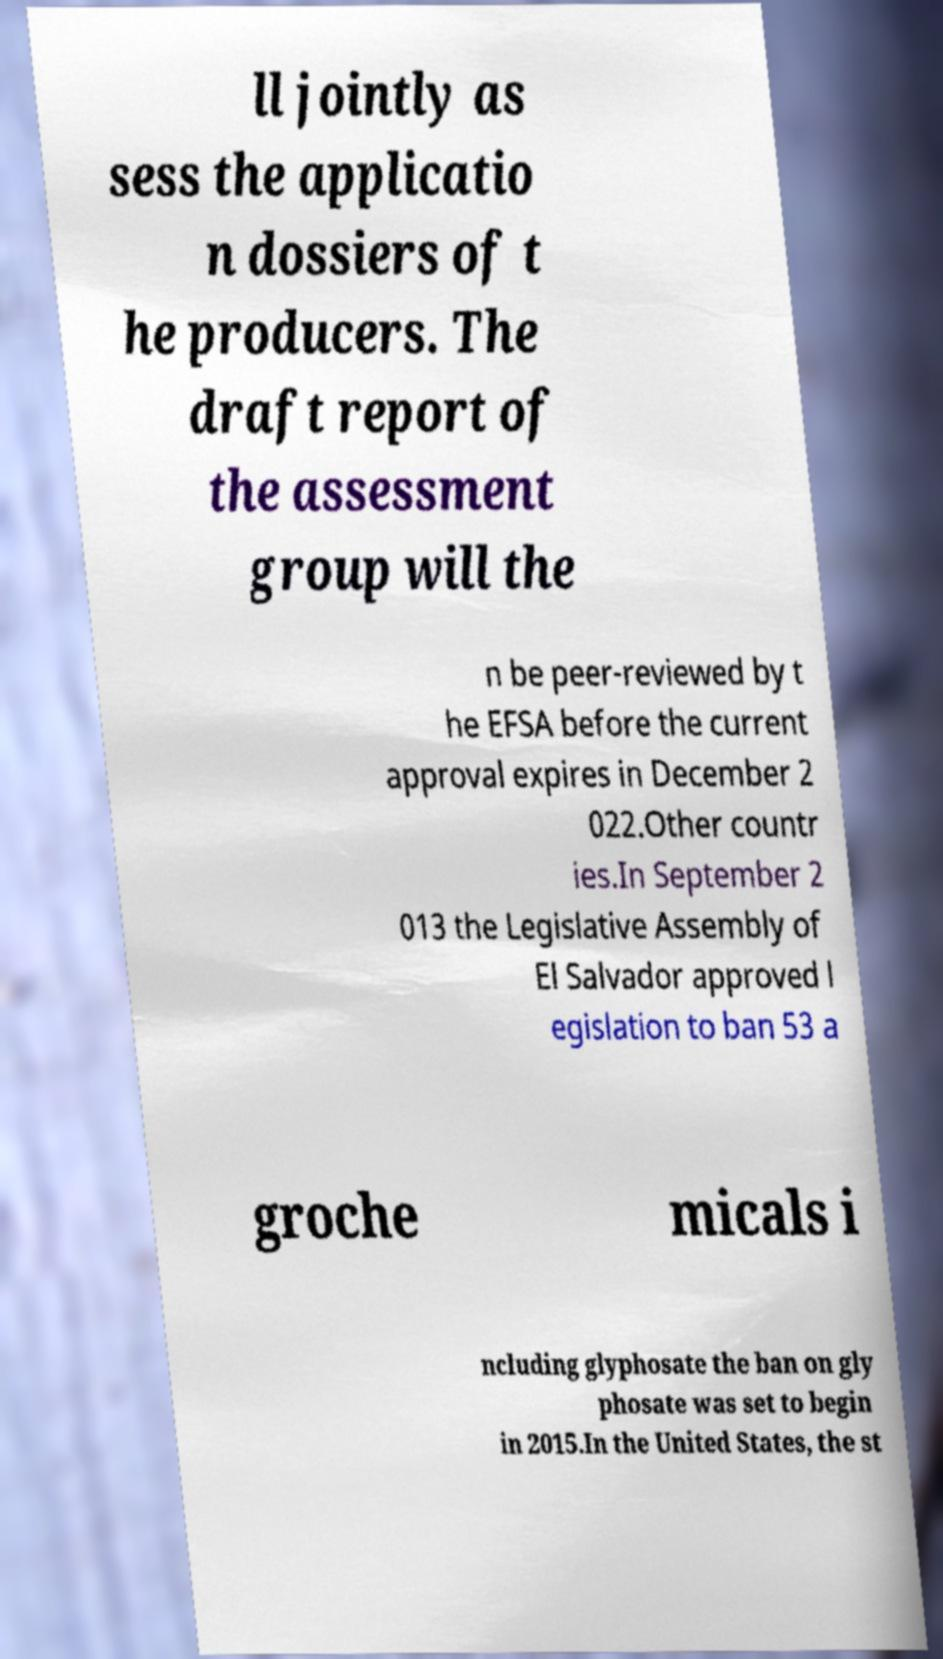Can you accurately transcribe the text from the provided image for me? ll jointly as sess the applicatio n dossiers of t he producers. The draft report of the assessment group will the n be peer-reviewed by t he EFSA before the current approval expires in December 2 022.Other countr ies.In September 2 013 the Legislative Assembly of El Salvador approved l egislation to ban 53 a groche micals i ncluding glyphosate the ban on gly phosate was set to begin in 2015.In the United States, the st 